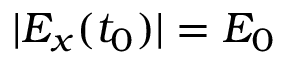Convert formula to latex. <formula><loc_0><loc_0><loc_500><loc_500>| E _ { x } ( t _ { 0 } ) | = E _ { 0 }</formula> 